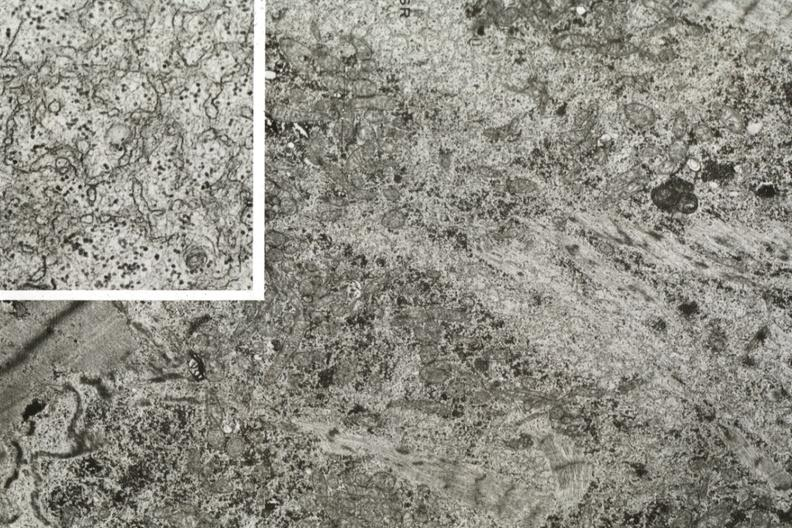what is present?
Answer the question using a single word or phrase. Cardiovascular 